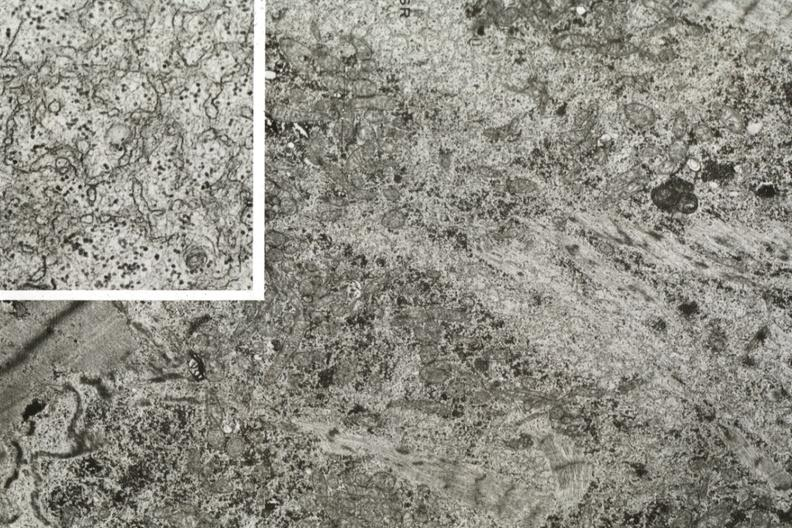what is present?
Answer the question using a single word or phrase. Cardiovascular 